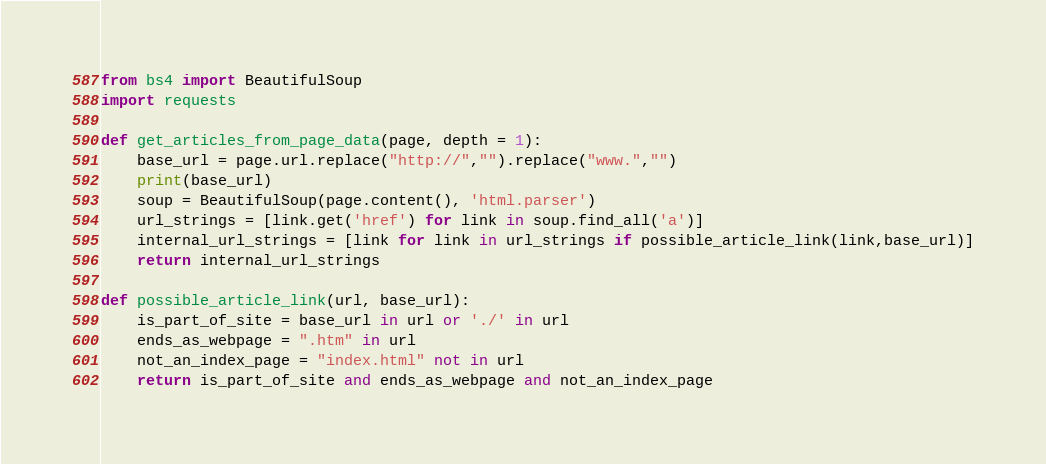<code> <loc_0><loc_0><loc_500><loc_500><_Python_>from bs4 import BeautifulSoup
import requests

def get_articles_from_page_data(page, depth = 1):
    base_url = page.url.replace("http://","").replace("www.","")
    print(base_url)
    soup = BeautifulSoup(page.content(), 'html.parser')
    url_strings = [link.get('href') for link in soup.find_all('a')]
    internal_url_strings = [link for link in url_strings if possible_article_link(link,base_url)]
    return internal_url_strings

def possible_article_link(url, base_url):
    is_part_of_site = base_url in url or './' in url
    ends_as_webpage = ".htm" in url
    not_an_index_page = "index.html" not in url
    return is_part_of_site and ends_as_webpage and not_an_index_page
</code> 